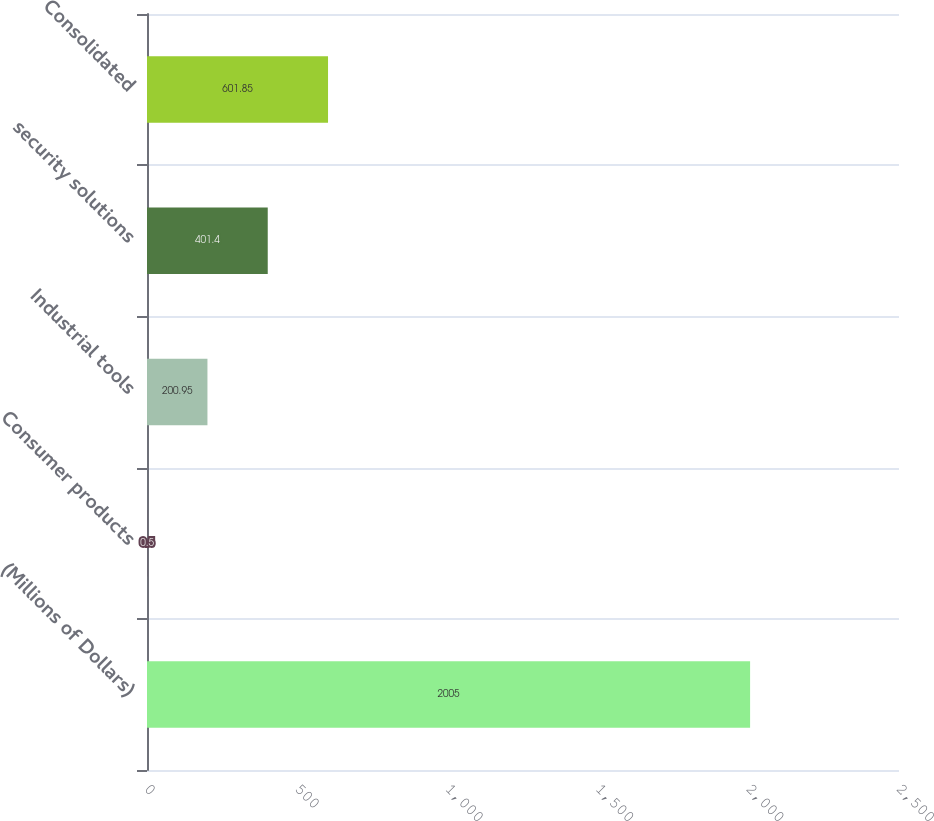Convert chart. <chart><loc_0><loc_0><loc_500><loc_500><bar_chart><fcel>(Millions of Dollars)<fcel>Consumer products<fcel>Industrial tools<fcel>security solutions<fcel>Consolidated<nl><fcel>2005<fcel>0.5<fcel>200.95<fcel>401.4<fcel>601.85<nl></chart> 